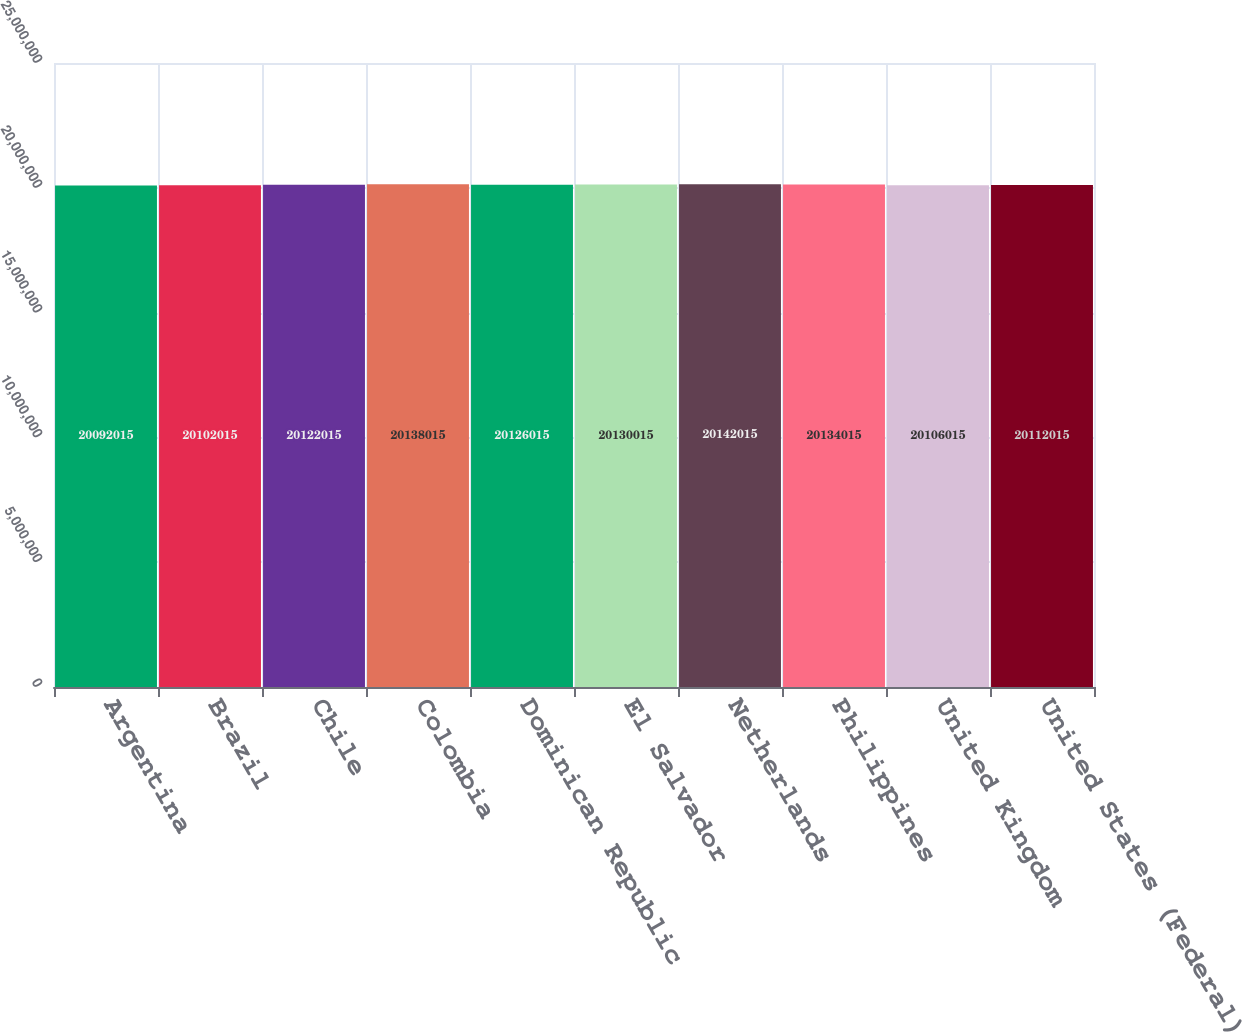Convert chart to OTSL. <chart><loc_0><loc_0><loc_500><loc_500><bar_chart><fcel>Argentina<fcel>Brazil<fcel>Chile<fcel>Colombia<fcel>Dominican Republic<fcel>El Salvador<fcel>Netherlands<fcel>Philippines<fcel>United Kingdom<fcel>United States (Federal)<nl><fcel>2.0092e+07<fcel>2.0102e+07<fcel>2.0122e+07<fcel>2.0138e+07<fcel>2.0126e+07<fcel>2.013e+07<fcel>2.0142e+07<fcel>2.0134e+07<fcel>2.0106e+07<fcel>2.0112e+07<nl></chart> 